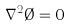Convert formula to latex. <formula><loc_0><loc_0><loc_500><loc_500>\nabla ^ { 2 } \emptyset = 0</formula> 